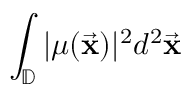<formula> <loc_0><loc_0><loc_500><loc_500>\int _ { \mathbb { D } } | \mu ( \vec { x } ) | ^ { 2 } d ^ { 2 } \vec { x }</formula> 